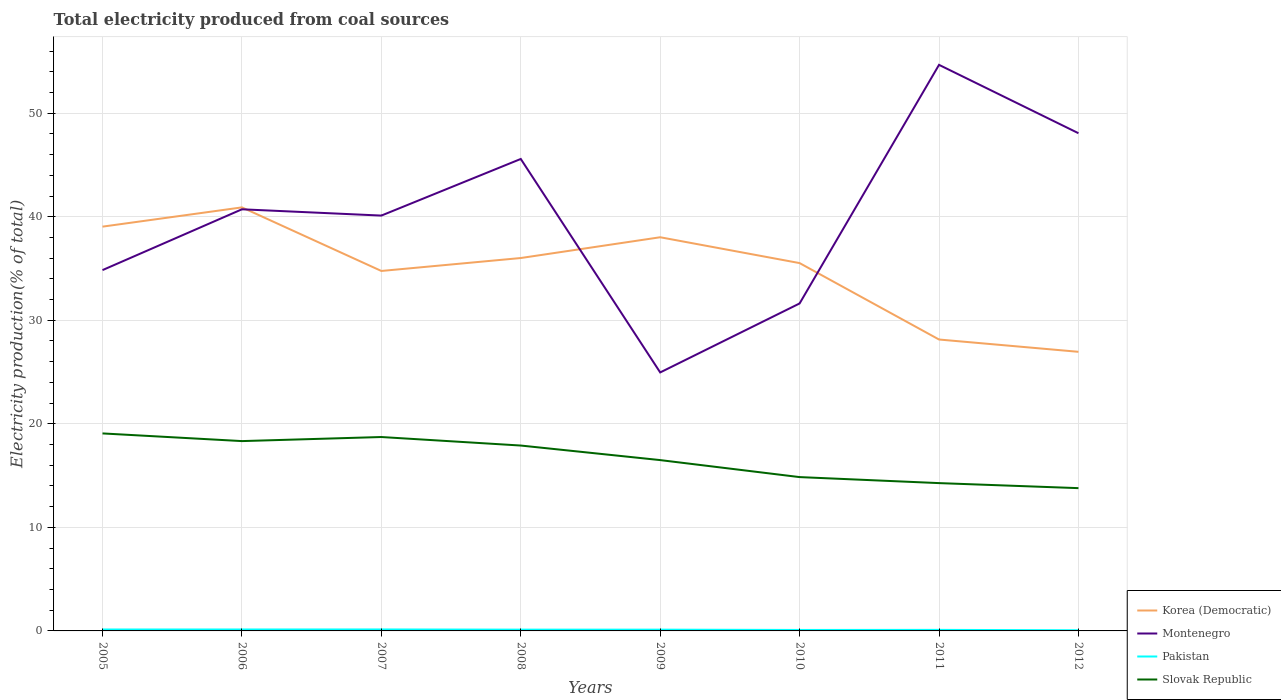Does the line corresponding to Montenegro intersect with the line corresponding to Slovak Republic?
Ensure brevity in your answer.  No. Is the number of lines equal to the number of legend labels?
Ensure brevity in your answer.  Yes. Across all years, what is the maximum total electricity produced in Pakistan?
Make the answer very short. 0.06. What is the total total electricity produced in Pakistan in the graph?
Give a very brief answer. 0.04. What is the difference between the highest and the second highest total electricity produced in Slovak Republic?
Ensure brevity in your answer.  5.29. What is the difference between the highest and the lowest total electricity produced in Slovak Republic?
Provide a short and direct response. 4. Is the total electricity produced in Montenegro strictly greater than the total electricity produced in Korea (Democratic) over the years?
Give a very brief answer. No. How many lines are there?
Provide a succinct answer. 4. How many years are there in the graph?
Provide a succinct answer. 8. What is the difference between two consecutive major ticks on the Y-axis?
Make the answer very short. 10. Does the graph contain any zero values?
Offer a terse response. No. Does the graph contain grids?
Give a very brief answer. Yes. Where does the legend appear in the graph?
Offer a very short reply. Bottom right. What is the title of the graph?
Provide a short and direct response. Total electricity produced from coal sources. What is the label or title of the X-axis?
Offer a terse response. Years. What is the Electricity production(% of total) in Korea (Democratic) in 2005?
Provide a short and direct response. 39.04. What is the Electricity production(% of total) in Montenegro in 2005?
Keep it short and to the point. 34.85. What is the Electricity production(% of total) in Pakistan in 2005?
Provide a succinct answer. 0.14. What is the Electricity production(% of total) in Slovak Republic in 2005?
Give a very brief answer. 19.07. What is the Electricity production(% of total) in Korea (Democratic) in 2006?
Provide a short and direct response. 40.9. What is the Electricity production(% of total) of Montenegro in 2006?
Keep it short and to the point. 40.72. What is the Electricity production(% of total) of Pakistan in 2006?
Offer a very short reply. 0.14. What is the Electricity production(% of total) of Slovak Republic in 2006?
Your answer should be very brief. 18.33. What is the Electricity production(% of total) in Korea (Democratic) in 2007?
Your answer should be very brief. 34.76. What is the Electricity production(% of total) in Montenegro in 2007?
Keep it short and to the point. 40.11. What is the Electricity production(% of total) in Pakistan in 2007?
Your answer should be compact. 0.14. What is the Electricity production(% of total) of Slovak Republic in 2007?
Provide a succinct answer. 18.73. What is the Electricity production(% of total) in Korea (Democratic) in 2008?
Your answer should be compact. 36.01. What is the Electricity production(% of total) in Montenegro in 2008?
Your answer should be compact. 45.58. What is the Electricity production(% of total) in Pakistan in 2008?
Give a very brief answer. 0.12. What is the Electricity production(% of total) of Slovak Republic in 2008?
Provide a succinct answer. 17.9. What is the Electricity production(% of total) in Korea (Democratic) in 2009?
Your answer should be very brief. 38.02. What is the Electricity production(% of total) in Montenegro in 2009?
Give a very brief answer. 24.96. What is the Electricity production(% of total) in Pakistan in 2009?
Your response must be concise. 0.12. What is the Electricity production(% of total) of Slovak Republic in 2009?
Your answer should be compact. 16.5. What is the Electricity production(% of total) in Korea (Democratic) in 2010?
Offer a very short reply. 35.52. What is the Electricity production(% of total) in Montenegro in 2010?
Your answer should be compact. 31.63. What is the Electricity production(% of total) in Pakistan in 2010?
Your response must be concise. 0.09. What is the Electricity production(% of total) of Slovak Republic in 2010?
Provide a succinct answer. 14.86. What is the Electricity production(% of total) of Korea (Democratic) in 2011?
Make the answer very short. 28.14. What is the Electricity production(% of total) of Montenegro in 2011?
Provide a succinct answer. 54.67. What is the Electricity production(% of total) of Pakistan in 2011?
Offer a very short reply. 0.1. What is the Electricity production(% of total) of Slovak Republic in 2011?
Your answer should be compact. 14.27. What is the Electricity production(% of total) of Korea (Democratic) in 2012?
Ensure brevity in your answer.  26.95. What is the Electricity production(% of total) in Montenegro in 2012?
Provide a succinct answer. 48.07. What is the Electricity production(% of total) of Pakistan in 2012?
Keep it short and to the point. 0.06. What is the Electricity production(% of total) of Slovak Republic in 2012?
Provide a succinct answer. 13.79. Across all years, what is the maximum Electricity production(% of total) of Korea (Democratic)?
Your answer should be very brief. 40.9. Across all years, what is the maximum Electricity production(% of total) of Montenegro?
Offer a very short reply. 54.67. Across all years, what is the maximum Electricity production(% of total) of Pakistan?
Offer a very short reply. 0.14. Across all years, what is the maximum Electricity production(% of total) of Slovak Republic?
Provide a short and direct response. 19.07. Across all years, what is the minimum Electricity production(% of total) in Korea (Democratic)?
Your response must be concise. 26.95. Across all years, what is the minimum Electricity production(% of total) in Montenegro?
Your response must be concise. 24.96. Across all years, what is the minimum Electricity production(% of total) of Pakistan?
Provide a short and direct response. 0.06. Across all years, what is the minimum Electricity production(% of total) of Slovak Republic?
Your answer should be compact. 13.79. What is the total Electricity production(% of total) in Korea (Democratic) in the graph?
Keep it short and to the point. 279.36. What is the total Electricity production(% of total) of Montenegro in the graph?
Keep it short and to the point. 320.58. What is the total Electricity production(% of total) in Pakistan in the graph?
Your response must be concise. 0.92. What is the total Electricity production(% of total) of Slovak Republic in the graph?
Offer a very short reply. 133.45. What is the difference between the Electricity production(% of total) in Korea (Democratic) in 2005 and that in 2006?
Your answer should be very brief. -1.86. What is the difference between the Electricity production(% of total) in Montenegro in 2005 and that in 2006?
Give a very brief answer. -5.87. What is the difference between the Electricity production(% of total) of Pakistan in 2005 and that in 2006?
Provide a short and direct response. -0. What is the difference between the Electricity production(% of total) of Slovak Republic in 2005 and that in 2006?
Ensure brevity in your answer.  0.74. What is the difference between the Electricity production(% of total) in Korea (Democratic) in 2005 and that in 2007?
Offer a terse response. 4.28. What is the difference between the Electricity production(% of total) in Montenegro in 2005 and that in 2007?
Offer a very short reply. -5.27. What is the difference between the Electricity production(% of total) of Pakistan in 2005 and that in 2007?
Keep it short and to the point. -0. What is the difference between the Electricity production(% of total) of Slovak Republic in 2005 and that in 2007?
Provide a short and direct response. 0.35. What is the difference between the Electricity production(% of total) in Korea (Democratic) in 2005 and that in 2008?
Provide a short and direct response. 3.03. What is the difference between the Electricity production(% of total) in Montenegro in 2005 and that in 2008?
Provide a succinct answer. -10.73. What is the difference between the Electricity production(% of total) in Pakistan in 2005 and that in 2008?
Offer a terse response. 0.01. What is the difference between the Electricity production(% of total) in Slovak Republic in 2005 and that in 2008?
Make the answer very short. 1.17. What is the difference between the Electricity production(% of total) in Korea (Democratic) in 2005 and that in 2009?
Offer a very short reply. 1.02. What is the difference between the Electricity production(% of total) in Montenegro in 2005 and that in 2009?
Provide a succinct answer. 9.88. What is the difference between the Electricity production(% of total) in Pakistan in 2005 and that in 2009?
Keep it short and to the point. 0.02. What is the difference between the Electricity production(% of total) in Slovak Republic in 2005 and that in 2009?
Keep it short and to the point. 2.58. What is the difference between the Electricity production(% of total) of Korea (Democratic) in 2005 and that in 2010?
Offer a very short reply. 3.52. What is the difference between the Electricity production(% of total) in Montenegro in 2005 and that in 2010?
Offer a very short reply. 3.22. What is the difference between the Electricity production(% of total) of Pakistan in 2005 and that in 2010?
Offer a very short reply. 0.04. What is the difference between the Electricity production(% of total) of Slovak Republic in 2005 and that in 2010?
Provide a succinct answer. 4.22. What is the difference between the Electricity production(% of total) of Korea (Democratic) in 2005 and that in 2011?
Ensure brevity in your answer.  10.9. What is the difference between the Electricity production(% of total) in Montenegro in 2005 and that in 2011?
Give a very brief answer. -19.82. What is the difference between the Electricity production(% of total) in Pakistan in 2005 and that in 2011?
Offer a terse response. 0.04. What is the difference between the Electricity production(% of total) in Slovak Republic in 2005 and that in 2011?
Give a very brief answer. 4.8. What is the difference between the Electricity production(% of total) of Korea (Democratic) in 2005 and that in 2012?
Give a very brief answer. 12.09. What is the difference between the Electricity production(% of total) in Montenegro in 2005 and that in 2012?
Offer a terse response. -13.22. What is the difference between the Electricity production(% of total) of Pakistan in 2005 and that in 2012?
Offer a terse response. 0.07. What is the difference between the Electricity production(% of total) of Slovak Republic in 2005 and that in 2012?
Keep it short and to the point. 5.29. What is the difference between the Electricity production(% of total) of Korea (Democratic) in 2006 and that in 2007?
Give a very brief answer. 6.14. What is the difference between the Electricity production(% of total) in Montenegro in 2006 and that in 2007?
Keep it short and to the point. 0.61. What is the difference between the Electricity production(% of total) in Pakistan in 2006 and that in 2007?
Your response must be concise. -0. What is the difference between the Electricity production(% of total) in Slovak Republic in 2006 and that in 2007?
Offer a terse response. -0.39. What is the difference between the Electricity production(% of total) of Korea (Democratic) in 2006 and that in 2008?
Your answer should be very brief. 4.89. What is the difference between the Electricity production(% of total) of Montenegro in 2006 and that in 2008?
Your answer should be very brief. -4.86. What is the difference between the Electricity production(% of total) in Pakistan in 2006 and that in 2008?
Offer a terse response. 0.02. What is the difference between the Electricity production(% of total) of Slovak Republic in 2006 and that in 2008?
Your answer should be very brief. 0.43. What is the difference between the Electricity production(% of total) in Korea (Democratic) in 2006 and that in 2009?
Offer a very short reply. 2.88. What is the difference between the Electricity production(% of total) of Montenegro in 2006 and that in 2009?
Provide a short and direct response. 15.75. What is the difference between the Electricity production(% of total) in Pakistan in 2006 and that in 2009?
Keep it short and to the point. 0.02. What is the difference between the Electricity production(% of total) in Slovak Republic in 2006 and that in 2009?
Provide a short and direct response. 1.83. What is the difference between the Electricity production(% of total) of Korea (Democratic) in 2006 and that in 2010?
Your response must be concise. 5.38. What is the difference between the Electricity production(% of total) of Montenegro in 2006 and that in 2010?
Your answer should be very brief. 9.09. What is the difference between the Electricity production(% of total) in Pakistan in 2006 and that in 2010?
Make the answer very short. 0.05. What is the difference between the Electricity production(% of total) of Slovak Republic in 2006 and that in 2010?
Make the answer very short. 3.48. What is the difference between the Electricity production(% of total) of Korea (Democratic) in 2006 and that in 2011?
Keep it short and to the point. 12.76. What is the difference between the Electricity production(% of total) in Montenegro in 2006 and that in 2011?
Your answer should be very brief. -13.95. What is the difference between the Electricity production(% of total) in Pakistan in 2006 and that in 2011?
Offer a terse response. 0.04. What is the difference between the Electricity production(% of total) of Slovak Republic in 2006 and that in 2011?
Keep it short and to the point. 4.06. What is the difference between the Electricity production(% of total) in Korea (Democratic) in 2006 and that in 2012?
Your response must be concise. 13.95. What is the difference between the Electricity production(% of total) in Montenegro in 2006 and that in 2012?
Your answer should be compact. -7.35. What is the difference between the Electricity production(% of total) in Pakistan in 2006 and that in 2012?
Offer a terse response. 0.07. What is the difference between the Electricity production(% of total) in Slovak Republic in 2006 and that in 2012?
Your response must be concise. 4.54. What is the difference between the Electricity production(% of total) in Korea (Democratic) in 2007 and that in 2008?
Your response must be concise. -1.25. What is the difference between the Electricity production(% of total) in Montenegro in 2007 and that in 2008?
Make the answer very short. -5.47. What is the difference between the Electricity production(% of total) in Pakistan in 2007 and that in 2008?
Make the answer very short. 0.02. What is the difference between the Electricity production(% of total) of Slovak Republic in 2007 and that in 2008?
Keep it short and to the point. 0.82. What is the difference between the Electricity production(% of total) of Korea (Democratic) in 2007 and that in 2009?
Your answer should be very brief. -3.26. What is the difference between the Electricity production(% of total) in Montenegro in 2007 and that in 2009?
Your answer should be very brief. 15.15. What is the difference between the Electricity production(% of total) of Pakistan in 2007 and that in 2009?
Provide a short and direct response. 0.02. What is the difference between the Electricity production(% of total) of Slovak Republic in 2007 and that in 2009?
Provide a succinct answer. 2.23. What is the difference between the Electricity production(% of total) in Korea (Democratic) in 2007 and that in 2010?
Offer a terse response. -0.76. What is the difference between the Electricity production(% of total) in Montenegro in 2007 and that in 2010?
Your answer should be compact. 8.49. What is the difference between the Electricity production(% of total) in Pakistan in 2007 and that in 2010?
Provide a short and direct response. 0.05. What is the difference between the Electricity production(% of total) of Slovak Republic in 2007 and that in 2010?
Offer a terse response. 3.87. What is the difference between the Electricity production(% of total) in Korea (Democratic) in 2007 and that in 2011?
Provide a succinct answer. 6.62. What is the difference between the Electricity production(% of total) in Montenegro in 2007 and that in 2011?
Your response must be concise. -14.56. What is the difference between the Electricity production(% of total) in Pakistan in 2007 and that in 2011?
Give a very brief answer. 0.04. What is the difference between the Electricity production(% of total) of Slovak Republic in 2007 and that in 2011?
Give a very brief answer. 4.45. What is the difference between the Electricity production(% of total) of Korea (Democratic) in 2007 and that in 2012?
Offer a terse response. 7.81. What is the difference between the Electricity production(% of total) of Montenegro in 2007 and that in 2012?
Keep it short and to the point. -7.95. What is the difference between the Electricity production(% of total) in Pakistan in 2007 and that in 2012?
Make the answer very short. 0.08. What is the difference between the Electricity production(% of total) of Slovak Republic in 2007 and that in 2012?
Make the answer very short. 4.94. What is the difference between the Electricity production(% of total) of Korea (Democratic) in 2008 and that in 2009?
Your response must be concise. -2.01. What is the difference between the Electricity production(% of total) of Montenegro in 2008 and that in 2009?
Your response must be concise. 20.62. What is the difference between the Electricity production(% of total) in Pakistan in 2008 and that in 2009?
Offer a terse response. 0. What is the difference between the Electricity production(% of total) of Slovak Republic in 2008 and that in 2009?
Your answer should be compact. 1.41. What is the difference between the Electricity production(% of total) in Korea (Democratic) in 2008 and that in 2010?
Your answer should be compact. 0.49. What is the difference between the Electricity production(% of total) of Montenegro in 2008 and that in 2010?
Keep it short and to the point. 13.95. What is the difference between the Electricity production(% of total) of Pakistan in 2008 and that in 2010?
Your answer should be compact. 0.03. What is the difference between the Electricity production(% of total) in Slovak Republic in 2008 and that in 2010?
Your answer should be compact. 3.05. What is the difference between the Electricity production(% of total) in Korea (Democratic) in 2008 and that in 2011?
Provide a succinct answer. 7.87. What is the difference between the Electricity production(% of total) of Montenegro in 2008 and that in 2011?
Provide a short and direct response. -9.09. What is the difference between the Electricity production(% of total) of Pakistan in 2008 and that in 2011?
Provide a short and direct response. 0.02. What is the difference between the Electricity production(% of total) of Slovak Republic in 2008 and that in 2011?
Your response must be concise. 3.63. What is the difference between the Electricity production(% of total) in Korea (Democratic) in 2008 and that in 2012?
Offer a very short reply. 9.06. What is the difference between the Electricity production(% of total) of Montenegro in 2008 and that in 2012?
Make the answer very short. -2.49. What is the difference between the Electricity production(% of total) of Pakistan in 2008 and that in 2012?
Keep it short and to the point. 0.06. What is the difference between the Electricity production(% of total) of Slovak Republic in 2008 and that in 2012?
Ensure brevity in your answer.  4.11. What is the difference between the Electricity production(% of total) of Korea (Democratic) in 2009 and that in 2010?
Your answer should be very brief. 2.5. What is the difference between the Electricity production(% of total) in Montenegro in 2009 and that in 2010?
Ensure brevity in your answer.  -6.66. What is the difference between the Electricity production(% of total) in Pakistan in 2009 and that in 2010?
Your response must be concise. 0.03. What is the difference between the Electricity production(% of total) in Slovak Republic in 2009 and that in 2010?
Provide a short and direct response. 1.64. What is the difference between the Electricity production(% of total) in Korea (Democratic) in 2009 and that in 2011?
Provide a short and direct response. 9.88. What is the difference between the Electricity production(% of total) in Montenegro in 2009 and that in 2011?
Ensure brevity in your answer.  -29.7. What is the difference between the Electricity production(% of total) in Pakistan in 2009 and that in 2011?
Ensure brevity in your answer.  0.02. What is the difference between the Electricity production(% of total) of Slovak Republic in 2009 and that in 2011?
Ensure brevity in your answer.  2.22. What is the difference between the Electricity production(% of total) of Korea (Democratic) in 2009 and that in 2012?
Offer a terse response. 11.06. What is the difference between the Electricity production(% of total) of Montenegro in 2009 and that in 2012?
Your response must be concise. -23.1. What is the difference between the Electricity production(% of total) in Pakistan in 2009 and that in 2012?
Your response must be concise. 0.06. What is the difference between the Electricity production(% of total) of Slovak Republic in 2009 and that in 2012?
Your response must be concise. 2.71. What is the difference between the Electricity production(% of total) of Korea (Democratic) in 2010 and that in 2011?
Ensure brevity in your answer.  7.38. What is the difference between the Electricity production(% of total) of Montenegro in 2010 and that in 2011?
Provide a short and direct response. -23.04. What is the difference between the Electricity production(% of total) of Pakistan in 2010 and that in 2011?
Offer a very short reply. -0.01. What is the difference between the Electricity production(% of total) in Slovak Republic in 2010 and that in 2011?
Keep it short and to the point. 0.58. What is the difference between the Electricity production(% of total) in Korea (Democratic) in 2010 and that in 2012?
Your answer should be compact. 8.57. What is the difference between the Electricity production(% of total) in Montenegro in 2010 and that in 2012?
Give a very brief answer. -16.44. What is the difference between the Electricity production(% of total) of Pakistan in 2010 and that in 2012?
Give a very brief answer. 0.03. What is the difference between the Electricity production(% of total) in Slovak Republic in 2010 and that in 2012?
Your response must be concise. 1.07. What is the difference between the Electricity production(% of total) of Korea (Democratic) in 2011 and that in 2012?
Give a very brief answer. 1.19. What is the difference between the Electricity production(% of total) in Montenegro in 2011 and that in 2012?
Offer a terse response. 6.6. What is the difference between the Electricity production(% of total) of Pakistan in 2011 and that in 2012?
Ensure brevity in your answer.  0.04. What is the difference between the Electricity production(% of total) of Slovak Republic in 2011 and that in 2012?
Your response must be concise. 0.49. What is the difference between the Electricity production(% of total) of Korea (Democratic) in 2005 and the Electricity production(% of total) of Montenegro in 2006?
Your answer should be very brief. -1.67. What is the difference between the Electricity production(% of total) of Korea (Democratic) in 2005 and the Electricity production(% of total) of Pakistan in 2006?
Provide a succinct answer. 38.9. What is the difference between the Electricity production(% of total) of Korea (Democratic) in 2005 and the Electricity production(% of total) of Slovak Republic in 2006?
Keep it short and to the point. 20.71. What is the difference between the Electricity production(% of total) in Montenegro in 2005 and the Electricity production(% of total) in Pakistan in 2006?
Your response must be concise. 34.71. What is the difference between the Electricity production(% of total) in Montenegro in 2005 and the Electricity production(% of total) in Slovak Republic in 2006?
Provide a short and direct response. 16.51. What is the difference between the Electricity production(% of total) in Pakistan in 2005 and the Electricity production(% of total) in Slovak Republic in 2006?
Your response must be concise. -18.19. What is the difference between the Electricity production(% of total) of Korea (Democratic) in 2005 and the Electricity production(% of total) of Montenegro in 2007?
Provide a succinct answer. -1.07. What is the difference between the Electricity production(% of total) of Korea (Democratic) in 2005 and the Electricity production(% of total) of Pakistan in 2007?
Your answer should be very brief. 38.9. What is the difference between the Electricity production(% of total) of Korea (Democratic) in 2005 and the Electricity production(% of total) of Slovak Republic in 2007?
Your answer should be compact. 20.32. What is the difference between the Electricity production(% of total) in Montenegro in 2005 and the Electricity production(% of total) in Pakistan in 2007?
Offer a terse response. 34.7. What is the difference between the Electricity production(% of total) in Montenegro in 2005 and the Electricity production(% of total) in Slovak Republic in 2007?
Provide a succinct answer. 16.12. What is the difference between the Electricity production(% of total) of Pakistan in 2005 and the Electricity production(% of total) of Slovak Republic in 2007?
Your answer should be compact. -18.59. What is the difference between the Electricity production(% of total) in Korea (Democratic) in 2005 and the Electricity production(% of total) in Montenegro in 2008?
Offer a terse response. -6.54. What is the difference between the Electricity production(% of total) of Korea (Democratic) in 2005 and the Electricity production(% of total) of Pakistan in 2008?
Your answer should be very brief. 38.92. What is the difference between the Electricity production(% of total) in Korea (Democratic) in 2005 and the Electricity production(% of total) in Slovak Republic in 2008?
Offer a very short reply. 21.14. What is the difference between the Electricity production(% of total) of Montenegro in 2005 and the Electricity production(% of total) of Pakistan in 2008?
Make the answer very short. 34.72. What is the difference between the Electricity production(% of total) in Montenegro in 2005 and the Electricity production(% of total) in Slovak Republic in 2008?
Your response must be concise. 16.94. What is the difference between the Electricity production(% of total) in Pakistan in 2005 and the Electricity production(% of total) in Slovak Republic in 2008?
Provide a short and direct response. -17.77. What is the difference between the Electricity production(% of total) in Korea (Democratic) in 2005 and the Electricity production(% of total) in Montenegro in 2009?
Keep it short and to the point. 14.08. What is the difference between the Electricity production(% of total) in Korea (Democratic) in 2005 and the Electricity production(% of total) in Pakistan in 2009?
Offer a very short reply. 38.92. What is the difference between the Electricity production(% of total) of Korea (Democratic) in 2005 and the Electricity production(% of total) of Slovak Republic in 2009?
Your response must be concise. 22.55. What is the difference between the Electricity production(% of total) of Montenegro in 2005 and the Electricity production(% of total) of Pakistan in 2009?
Give a very brief answer. 34.72. What is the difference between the Electricity production(% of total) of Montenegro in 2005 and the Electricity production(% of total) of Slovak Republic in 2009?
Your response must be concise. 18.35. What is the difference between the Electricity production(% of total) in Pakistan in 2005 and the Electricity production(% of total) in Slovak Republic in 2009?
Your response must be concise. -16.36. What is the difference between the Electricity production(% of total) of Korea (Democratic) in 2005 and the Electricity production(% of total) of Montenegro in 2010?
Offer a terse response. 7.42. What is the difference between the Electricity production(% of total) in Korea (Democratic) in 2005 and the Electricity production(% of total) in Pakistan in 2010?
Provide a succinct answer. 38.95. What is the difference between the Electricity production(% of total) of Korea (Democratic) in 2005 and the Electricity production(% of total) of Slovak Republic in 2010?
Your response must be concise. 24.19. What is the difference between the Electricity production(% of total) of Montenegro in 2005 and the Electricity production(% of total) of Pakistan in 2010?
Offer a terse response. 34.75. What is the difference between the Electricity production(% of total) in Montenegro in 2005 and the Electricity production(% of total) in Slovak Republic in 2010?
Your response must be concise. 19.99. What is the difference between the Electricity production(% of total) in Pakistan in 2005 and the Electricity production(% of total) in Slovak Republic in 2010?
Provide a succinct answer. -14.72. What is the difference between the Electricity production(% of total) in Korea (Democratic) in 2005 and the Electricity production(% of total) in Montenegro in 2011?
Provide a succinct answer. -15.63. What is the difference between the Electricity production(% of total) in Korea (Democratic) in 2005 and the Electricity production(% of total) in Pakistan in 2011?
Provide a succinct answer. 38.94. What is the difference between the Electricity production(% of total) in Korea (Democratic) in 2005 and the Electricity production(% of total) in Slovak Republic in 2011?
Your answer should be compact. 24.77. What is the difference between the Electricity production(% of total) in Montenegro in 2005 and the Electricity production(% of total) in Pakistan in 2011?
Keep it short and to the point. 34.75. What is the difference between the Electricity production(% of total) in Montenegro in 2005 and the Electricity production(% of total) in Slovak Republic in 2011?
Keep it short and to the point. 20.57. What is the difference between the Electricity production(% of total) in Pakistan in 2005 and the Electricity production(% of total) in Slovak Republic in 2011?
Your answer should be compact. -14.14. What is the difference between the Electricity production(% of total) in Korea (Democratic) in 2005 and the Electricity production(% of total) in Montenegro in 2012?
Offer a terse response. -9.02. What is the difference between the Electricity production(% of total) of Korea (Democratic) in 2005 and the Electricity production(% of total) of Pakistan in 2012?
Ensure brevity in your answer.  38.98. What is the difference between the Electricity production(% of total) of Korea (Democratic) in 2005 and the Electricity production(% of total) of Slovak Republic in 2012?
Your answer should be very brief. 25.25. What is the difference between the Electricity production(% of total) in Montenegro in 2005 and the Electricity production(% of total) in Pakistan in 2012?
Offer a very short reply. 34.78. What is the difference between the Electricity production(% of total) of Montenegro in 2005 and the Electricity production(% of total) of Slovak Republic in 2012?
Provide a succinct answer. 21.06. What is the difference between the Electricity production(% of total) of Pakistan in 2005 and the Electricity production(% of total) of Slovak Republic in 2012?
Provide a succinct answer. -13.65. What is the difference between the Electricity production(% of total) of Korea (Democratic) in 2006 and the Electricity production(% of total) of Montenegro in 2007?
Provide a short and direct response. 0.79. What is the difference between the Electricity production(% of total) in Korea (Democratic) in 2006 and the Electricity production(% of total) in Pakistan in 2007?
Keep it short and to the point. 40.76. What is the difference between the Electricity production(% of total) in Korea (Democratic) in 2006 and the Electricity production(% of total) in Slovak Republic in 2007?
Make the answer very short. 22.18. What is the difference between the Electricity production(% of total) of Montenegro in 2006 and the Electricity production(% of total) of Pakistan in 2007?
Ensure brevity in your answer.  40.58. What is the difference between the Electricity production(% of total) of Montenegro in 2006 and the Electricity production(% of total) of Slovak Republic in 2007?
Provide a succinct answer. 21.99. What is the difference between the Electricity production(% of total) in Pakistan in 2006 and the Electricity production(% of total) in Slovak Republic in 2007?
Provide a succinct answer. -18.59. What is the difference between the Electricity production(% of total) of Korea (Democratic) in 2006 and the Electricity production(% of total) of Montenegro in 2008?
Provide a succinct answer. -4.68. What is the difference between the Electricity production(% of total) in Korea (Democratic) in 2006 and the Electricity production(% of total) in Pakistan in 2008?
Your response must be concise. 40.78. What is the difference between the Electricity production(% of total) of Korea (Democratic) in 2006 and the Electricity production(% of total) of Slovak Republic in 2008?
Your response must be concise. 23. What is the difference between the Electricity production(% of total) of Montenegro in 2006 and the Electricity production(% of total) of Pakistan in 2008?
Provide a succinct answer. 40.59. What is the difference between the Electricity production(% of total) of Montenegro in 2006 and the Electricity production(% of total) of Slovak Republic in 2008?
Your answer should be compact. 22.81. What is the difference between the Electricity production(% of total) of Pakistan in 2006 and the Electricity production(% of total) of Slovak Republic in 2008?
Your response must be concise. -17.76. What is the difference between the Electricity production(% of total) in Korea (Democratic) in 2006 and the Electricity production(% of total) in Montenegro in 2009?
Your response must be concise. 15.94. What is the difference between the Electricity production(% of total) in Korea (Democratic) in 2006 and the Electricity production(% of total) in Pakistan in 2009?
Ensure brevity in your answer.  40.78. What is the difference between the Electricity production(% of total) of Korea (Democratic) in 2006 and the Electricity production(% of total) of Slovak Republic in 2009?
Your response must be concise. 24.41. What is the difference between the Electricity production(% of total) in Montenegro in 2006 and the Electricity production(% of total) in Pakistan in 2009?
Provide a short and direct response. 40.6. What is the difference between the Electricity production(% of total) in Montenegro in 2006 and the Electricity production(% of total) in Slovak Republic in 2009?
Your response must be concise. 24.22. What is the difference between the Electricity production(% of total) of Pakistan in 2006 and the Electricity production(% of total) of Slovak Republic in 2009?
Offer a very short reply. -16.36. What is the difference between the Electricity production(% of total) in Korea (Democratic) in 2006 and the Electricity production(% of total) in Montenegro in 2010?
Ensure brevity in your answer.  9.28. What is the difference between the Electricity production(% of total) in Korea (Democratic) in 2006 and the Electricity production(% of total) in Pakistan in 2010?
Offer a very short reply. 40.81. What is the difference between the Electricity production(% of total) of Korea (Democratic) in 2006 and the Electricity production(% of total) of Slovak Republic in 2010?
Your response must be concise. 26.05. What is the difference between the Electricity production(% of total) of Montenegro in 2006 and the Electricity production(% of total) of Pakistan in 2010?
Give a very brief answer. 40.62. What is the difference between the Electricity production(% of total) in Montenegro in 2006 and the Electricity production(% of total) in Slovak Republic in 2010?
Your response must be concise. 25.86. What is the difference between the Electricity production(% of total) of Pakistan in 2006 and the Electricity production(% of total) of Slovak Republic in 2010?
Keep it short and to the point. -14.72. What is the difference between the Electricity production(% of total) of Korea (Democratic) in 2006 and the Electricity production(% of total) of Montenegro in 2011?
Your answer should be very brief. -13.77. What is the difference between the Electricity production(% of total) in Korea (Democratic) in 2006 and the Electricity production(% of total) in Pakistan in 2011?
Make the answer very short. 40.8. What is the difference between the Electricity production(% of total) in Korea (Democratic) in 2006 and the Electricity production(% of total) in Slovak Republic in 2011?
Your answer should be very brief. 26.63. What is the difference between the Electricity production(% of total) of Montenegro in 2006 and the Electricity production(% of total) of Pakistan in 2011?
Make the answer very short. 40.62. What is the difference between the Electricity production(% of total) in Montenegro in 2006 and the Electricity production(% of total) in Slovak Republic in 2011?
Your response must be concise. 26.44. What is the difference between the Electricity production(% of total) in Pakistan in 2006 and the Electricity production(% of total) in Slovak Republic in 2011?
Ensure brevity in your answer.  -14.14. What is the difference between the Electricity production(% of total) of Korea (Democratic) in 2006 and the Electricity production(% of total) of Montenegro in 2012?
Offer a terse response. -7.16. What is the difference between the Electricity production(% of total) in Korea (Democratic) in 2006 and the Electricity production(% of total) in Pakistan in 2012?
Ensure brevity in your answer.  40.84. What is the difference between the Electricity production(% of total) of Korea (Democratic) in 2006 and the Electricity production(% of total) of Slovak Republic in 2012?
Offer a very short reply. 27.11. What is the difference between the Electricity production(% of total) of Montenegro in 2006 and the Electricity production(% of total) of Pakistan in 2012?
Keep it short and to the point. 40.65. What is the difference between the Electricity production(% of total) in Montenegro in 2006 and the Electricity production(% of total) in Slovak Republic in 2012?
Give a very brief answer. 26.93. What is the difference between the Electricity production(% of total) of Pakistan in 2006 and the Electricity production(% of total) of Slovak Republic in 2012?
Ensure brevity in your answer.  -13.65. What is the difference between the Electricity production(% of total) in Korea (Democratic) in 2007 and the Electricity production(% of total) in Montenegro in 2008?
Your answer should be compact. -10.82. What is the difference between the Electricity production(% of total) in Korea (Democratic) in 2007 and the Electricity production(% of total) in Pakistan in 2008?
Your answer should be very brief. 34.64. What is the difference between the Electricity production(% of total) of Korea (Democratic) in 2007 and the Electricity production(% of total) of Slovak Republic in 2008?
Your response must be concise. 16.86. What is the difference between the Electricity production(% of total) in Montenegro in 2007 and the Electricity production(% of total) in Pakistan in 2008?
Provide a short and direct response. 39.99. What is the difference between the Electricity production(% of total) in Montenegro in 2007 and the Electricity production(% of total) in Slovak Republic in 2008?
Your answer should be compact. 22.21. What is the difference between the Electricity production(% of total) of Pakistan in 2007 and the Electricity production(% of total) of Slovak Republic in 2008?
Provide a succinct answer. -17.76. What is the difference between the Electricity production(% of total) in Korea (Democratic) in 2007 and the Electricity production(% of total) in Montenegro in 2009?
Your answer should be compact. 9.8. What is the difference between the Electricity production(% of total) of Korea (Democratic) in 2007 and the Electricity production(% of total) of Pakistan in 2009?
Keep it short and to the point. 34.64. What is the difference between the Electricity production(% of total) in Korea (Democratic) in 2007 and the Electricity production(% of total) in Slovak Republic in 2009?
Offer a terse response. 18.27. What is the difference between the Electricity production(% of total) of Montenegro in 2007 and the Electricity production(% of total) of Pakistan in 2009?
Your answer should be compact. 39.99. What is the difference between the Electricity production(% of total) of Montenegro in 2007 and the Electricity production(% of total) of Slovak Republic in 2009?
Your answer should be very brief. 23.61. What is the difference between the Electricity production(% of total) of Pakistan in 2007 and the Electricity production(% of total) of Slovak Republic in 2009?
Provide a succinct answer. -16.36. What is the difference between the Electricity production(% of total) of Korea (Democratic) in 2007 and the Electricity production(% of total) of Montenegro in 2010?
Ensure brevity in your answer.  3.14. What is the difference between the Electricity production(% of total) in Korea (Democratic) in 2007 and the Electricity production(% of total) in Pakistan in 2010?
Your answer should be very brief. 34.67. What is the difference between the Electricity production(% of total) in Korea (Democratic) in 2007 and the Electricity production(% of total) in Slovak Republic in 2010?
Your response must be concise. 19.91. What is the difference between the Electricity production(% of total) in Montenegro in 2007 and the Electricity production(% of total) in Pakistan in 2010?
Offer a terse response. 40.02. What is the difference between the Electricity production(% of total) in Montenegro in 2007 and the Electricity production(% of total) in Slovak Republic in 2010?
Give a very brief answer. 25.26. What is the difference between the Electricity production(% of total) of Pakistan in 2007 and the Electricity production(% of total) of Slovak Republic in 2010?
Offer a very short reply. -14.71. What is the difference between the Electricity production(% of total) of Korea (Democratic) in 2007 and the Electricity production(% of total) of Montenegro in 2011?
Your answer should be very brief. -19.91. What is the difference between the Electricity production(% of total) of Korea (Democratic) in 2007 and the Electricity production(% of total) of Pakistan in 2011?
Give a very brief answer. 34.66. What is the difference between the Electricity production(% of total) in Korea (Democratic) in 2007 and the Electricity production(% of total) in Slovak Republic in 2011?
Give a very brief answer. 20.49. What is the difference between the Electricity production(% of total) of Montenegro in 2007 and the Electricity production(% of total) of Pakistan in 2011?
Your answer should be very brief. 40.01. What is the difference between the Electricity production(% of total) of Montenegro in 2007 and the Electricity production(% of total) of Slovak Republic in 2011?
Ensure brevity in your answer.  25.84. What is the difference between the Electricity production(% of total) of Pakistan in 2007 and the Electricity production(% of total) of Slovak Republic in 2011?
Provide a succinct answer. -14.13. What is the difference between the Electricity production(% of total) of Korea (Democratic) in 2007 and the Electricity production(% of total) of Montenegro in 2012?
Offer a very short reply. -13.3. What is the difference between the Electricity production(% of total) of Korea (Democratic) in 2007 and the Electricity production(% of total) of Pakistan in 2012?
Offer a terse response. 34.7. What is the difference between the Electricity production(% of total) in Korea (Democratic) in 2007 and the Electricity production(% of total) in Slovak Republic in 2012?
Your answer should be very brief. 20.97. What is the difference between the Electricity production(% of total) of Montenegro in 2007 and the Electricity production(% of total) of Pakistan in 2012?
Your answer should be very brief. 40.05. What is the difference between the Electricity production(% of total) of Montenegro in 2007 and the Electricity production(% of total) of Slovak Republic in 2012?
Keep it short and to the point. 26.32. What is the difference between the Electricity production(% of total) in Pakistan in 2007 and the Electricity production(% of total) in Slovak Republic in 2012?
Make the answer very short. -13.65. What is the difference between the Electricity production(% of total) in Korea (Democratic) in 2008 and the Electricity production(% of total) in Montenegro in 2009?
Your response must be concise. 11.05. What is the difference between the Electricity production(% of total) of Korea (Democratic) in 2008 and the Electricity production(% of total) of Pakistan in 2009?
Give a very brief answer. 35.89. What is the difference between the Electricity production(% of total) of Korea (Democratic) in 2008 and the Electricity production(% of total) of Slovak Republic in 2009?
Keep it short and to the point. 19.51. What is the difference between the Electricity production(% of total) in Montenegro in 2008 and the Electricity production(% of total) in Pakistan in 2009?
Your response must be concise. 45.46. What is the difference between the Electricity production(% of total) in Montenegro in 2008 and the Electricity production(% of total) in Slovak Republic in 2009?
Ensure brevity in your answer.  29.08. What is the difference between the Electricity production(% of total) of Pakistan in 2008 and the Electricity production(% of total) of Slovak Republic in 2009?
Ensure brevity in your answer.  -16.37. What is the difference between the Electricity production(% of total) in Korea (Democratic) in 2008 and the Electricity production(% of total) in Montenegro in 2010?
Your answer should be compact. 4.39. What is the difference between the Electricity production(% of total) in Korea (Democratic) in 2008 and the Electricity production(% of total) in Pakistan in 2010?
Keep it short and to the point. 35.92. What is the difference between the Electricity production(% of total) in Korea (Democratic) in 2008 and the Electricity production(% of total) in Slovak Republic in 2010?
Your answer should be very brief. 21.16. What is the difference between the Electricity production(% of total) in Montenegro in 2008 and the Electricity production(% of total) in Pakistan in 2010?
Provide a short and direct response. 45.49. What is the difference between the Electricity production(% of total) of Montenegro in 2008 and the Electricity production(% of total) of Slovak Republic in 2010?
Offer a terse response. 30.72. What is the difference between the Electricity production(% of total) in Pakistan in 2008 and the Electricity production(% of total) in Slovak Republic in 2010?
Offer a very short reply. -14.73. What is the difference between the Electricity production(% of total) of Korea (Democratic) in 2008 and the Electricity production(% of total) of Montenegro in 2011?
Make the answer very short. -18.66. What is the difference between the Electricity production(% of total) in Korea (Democratic) in 2008 and the Electricity production(% of total) in Pakistan in 2011?
Your answer should be compact. 35.91. What is the difference between the Electricity production(% of total) in Korea (Democratic) in 2008 and the Electricity production(% of total) in Slovak Republic in 2011?
Offer a terse response. 21.74. What is the difference between the Electricity production(% of total) of Montenegro in 2008 and the Electricity production(% of total) of Pakistan in 2011?
Your answer should be very brief. 45.48. What is the difference between the Electricity production(% of total) in Montenegro in 2008 and the Electricity production(% of total) in Slovak Republic in 2011?
Your answer should be very brief. 31.31. What is the difference between the Electricity production(% of total) of Pakistan in 2008 and the Electricity production(% of total) of Slovak Republic in 2011?
Your response must be concise. -14.15. What is the difference between the Electricity production(% of total) in Korea (Democratic) in 2008 and the Electricity production(% of total) in Montenegro in 2012?
Your answer should be compact. -12.05. What is the difference between the Electricity production(% of total) of Korea (Democratic) in 2008 and the Electricity production(% of total) of Pakistan in 2012?
Provide a short and direct response. 35.95. What is the difference between the Electricity production(% of total) in Korea (Democratic) in 2008 and the Electricity production(% of total) in Slovak Republic in 2012?
Provide a succinct answer. 22.22. What is the difference between the Electricity production(% of total) of Montenegro in 2008 and the Electricity production(% of total) of Pakistan in 2012?
Provide a short and direct response. 45.52. What is the difference between the Electricity production(% of total) of Montenegro in 2008 and the Electricity production(% of total) of Slovak Republic in 2012?
Your answer should be very brief. 31.79. What is the difference between the Electricity production(% of total) of Pakistan in 2008 and the Electricity production(% of total) of Slovak Republic in 2012?
Your response must be concise. -13.67. What is the difference between the Electricity production(% of total) of Korea (Democratic) in 2009 and the Electricity production(% of total) of Montenegro in 2010?
Your answer should be very brief. 6.39. What is the difference between the Electricity production(% of total) of Korea (Democratic) in 2009 and the Electricity production(% of total) of Pakistan in 2010?
Your response must be concise. 37.93. What is the difference between the Electricity production(% of total) in Korea (Democratic) in 2009 and the Electricity production(% of total) in Slovak Republic in 2010?
Give a very brief answer. 23.16. What is the difference between the Electricity production(% of total) of Montenegro in 2009 and the Electricity production(% of total) of Pakistan in 2010?
Offer a terse response. 24.87. What is the difference between the Electricity production(% of total) of Montenegro in 2009 and the Electricity production(% of total) of Slovak Republic in 2010?
Provide a short and direct response. 10.11. What is the difference between the Electricity production(% of total) of Pakistan in 2009 and the Electricity production(% of total) of Slovak Republic in 2010?
Your answer should be compact. -14.73. What is the difference between the Electricity production(% of total) in Korea (Democratic) in 2009 and the Electricity production(% of total) in Montenegro in 2011?
Offer a terse response. -16.65. What is the difference between the Electricity production(% of total) of Korea (Democratic) in 2009 and the Electricity production(% of total) of Pakistan in 2011?
Your response must be concise. 37.92. What is the difference between the Electricity production(% of total) of Korea (Democratic) in 2009 and the Electricity production(% of total) of Slovak Republic in 2011?
Offer a terse response. 23.74. What is the difference between the Electricity production(% of total) in Montenegro in 2009 and the Electricity production(% of total) in Pakistan in 2011?
Ensure brevity in your answer.  24.86. What is the difference between the Electricity production(% of total) of Montenegro in 2009 and the Electricity production(% of total) of Slovak Republic in 2011?
Provide a short and direct response. 10.69. What is the difference between the Electricity production(% of total) in Pakistan in 2009 and the Electricity production(% of total) in Slovak Republic in 2011?
Provide a succinct answer. -14.15. What is the difference between the Electricity production(% of total) in Korea (Democratic) in 2009 and the Electricity production(% of total) in Montenegro in 2012?
Ensure brevity in your answer.  -10.05. What is the difference between the Electricity production(% of total) in Korea (Democratic) in 2009 and the Electricity production(% of total) in Pakistan in 2012?
Offer a very short reply. 37.96. What is the difference between the Electricity production(% of total) of Korea (Democratic) in 2009 and the Electricity production(% of total) of Slovak Republic in 2012?
Keep it short and to the point. 24.23. What is the difference between the Electricity production(% of total) of Montenegro in 2009 and the Electricity production(% of total) of Pakistan in 2012?
Offer a terse response. 24.9. What is the difference between the Electricity production(% of total) in Montenegro in 2009 and the Electricity production(% of total) in Slovak Republic in 2012?
Ensure brevity in your answer.  11.18. What is the difference between the Electricity production(% of total) of Pakistan in 2009 and the Electricity production(% of total) of Slovak Republic in 2012?
Your answer should be very brief. -13.67. What is the difference between the Electricity production(% of total) of Korea (Democratic) in 2010 and the Electricity production(% of total) of Montenegro in 2011?
Offer a terse response. -19.15. What is the difference between the Electricity production(% of total) in Korea (Democratic) in 2010 and the Electricity production(% of total) in Pakistan in 2011?
Offer a very short reply. 35.42. What is the difference between the Electricity production(% of total) in Korea (Democratic) in 2010 and the Electricity production(% of total) in Slovak Republic in 2011?
Offer a terse response. 21.25. What is the difference between the Electricity production(% of total) of Montenegro in 2010 and the Electricity production(% of total) of Pakistan in 2011?
Provide a succinct answer. 31.53. What is the difference between the Electricity production(% of total) in Montenegro in 2010 and the Electricity production(% of total) in Slovak Republic in 2011?
Make the answer very short. 17.35. What is the difference between the Electricity production(% of total) in Pakistan in 2010 and the Electricity production(% of total) in Slovak Republic in 2011?
Ensure brevity in your answer.  -14.18. What is the difference between the Electricity production(% of total) of Korea (Democratic) in 2010 and the Electricity production(% of total) of Montenegro in 2012?
Offer a very short reply. -12.54. What is the difference between the Electricity production(% of total) in Korea (Democratic) in 2010 and the Electricity production(% of total) in Pakistan in 2012?
Provide a short and direct response. 35.46. What is the difference between the Electricity production(% of total) in Korea (Democratic) in 2010 and the Electricity production(% of total) in Slovak Republic in 2012?
Give a very brief answer. 21.73. What is the difference between the Electricity production(% of total) of Montenegro in 2010 and the Electricity production(% of total) of Pakistan in 2012?
Your response must be concise. 31.56. What is the difference between the Electricity production(% of total) in Montenegro in 2010 and the Electricity production(% of total) in Slovak Republic in 2012?
Give a very brief answer. 17.84. What is the difference between the Electricity production(% of total) of Pakistan in 2010 and the Electricity production(% of total) of Slovak Republic in 2012?
Your answer should be very brief. -13.7. What is the difference between the Electricity production(% of total) of Korea (Democratic) in 2011 and the Electricity production(% of total) of Montenegro in 2012?
Your answer should be compact. -19.92. What is the difference between the Electricity production(% of total) of Korea (Democratic) in 2011 and the Electricity production(% of total) of Pakistan in 2012?
Provide a succinct answer. 28.08. What is the difference between the Electricity production(% of total) of Korea (Democratic) in 2011 and the Electricity production(% of total) of Slovak Republic in 2012?
Offer a terse response. 14.35. What is the difference between the Electricity production(% of total) of Montenegro in 2011 and the Electricity production(% of total) of Pakistan in 2012?
Your response must be concise. 54.61. What is the difference between the Electricity production(% of total) of Montenegro in 2011 and the Electricity production(% of total) of Slovak Republic in 2012?
Make the answer very short. 40.88. What is the difference between the Electricity production(% of total) in Pakistan in 2011 and the Electricity production(% of total) in Slovak Republic in 2012?
Keep it short and to the point. -13.69. What is the average Electricity production(% of total) in Korea (Democratic) per year?
Make the answer very short. 34.92. What is the average Electricity production(% of total) of Montenegro per year?
Your response must be concise. 40.07. What is the average Electricity production(% of total) in Pakistan per year?
Your response must be concise. 0.12. What is the average Electricity production(% of total) in Slovak Republic per year?
Provide a short and direct response. 16.68. In the year 2005, what is the difference between the Electricity production(% of total) in Korea (Democratic) and Electricity production(% of total) in Montenegro?
Your response must be concise. 4.2. In the year 2005, what is the difference between the Electricity production(% of total) of Korea (Democratic) and Electricity production(% of total) of Pakistan?
Keep it short and to the point. 38.91. In the year 2005, what is the difference between the Electricity production(% of total) in Korea (Democratic) and Electricity production(% of total) in Slovak Republic?
Give a very brief answer. 19.97. In the year 2005, what is the difference between the Electricity production(% of total) in Montenegro and Electricity production(% of total) in Pakistan?
Offer a very short reply. 34.71. In the year 2005, what is the difference between the Electricity production(% of total) in Montenegro and Electricity production(% of total) in Slovak Republic?
Give a very brief answer. 15.77. In the year 2005, what is the difference between the Electricity production(% of total) in Pakistan and Electricity production(% of total) in Slovak Republic?
Your answer should be very brief. -18.94. In the year 2006, what is the difference between the Electricity production(% of total) of Korea (Democratic) and Electricity production(% of total) of Montenegro?
Offer a terse response. 0.18. In the year 2006, what is the difference between the Electricity production(% of total) in Korea (Democratic) and Electricity production(% of total) in Pakistan?
Give a very brief answer. 40.76. In the year 2006, what is the difference between the Electricity production(% of total) in Korea (Democratic) and Electricity production(% of total) in Slovak Republic?
Your answer should be very brief. 22.57. In the year 2006, what is the difference between the Electricity production(% of total) of Montenegro and Electricity production(% of total) of Pakistan?
Ensure brevity in your answer.  40.58. In the year 2006, what is the difference between the Electricity production(% of total) in Montenegro and Electricity production(% of total) in Slovak Republic?
Your response must be concise. 22.39. In the year 2006, what is the difference between the Electricity production(% of total) of Pakistan and Electricity production(% of total) of Slovak Republic?
Your answer should be very brief. -18.19. In the year 2007, what is the difference between the Electricity production(% of total) in Korea (Democratic) and Electricity production(% of total) in Montenegro?
Keep it short and to the point. -5.35. In the year 2007, what is the difference between the Electricity production(% of total) in Korea (Democratic) and Electricity production(% of total) in Pakistan?
Ensure brevity in your answer.  34.62. In the year 2007, what is the difference between the Electricity production(% of total) in Korea (Democratic) and Electricity production(% of total) in Slovak Republic?
Your answer should be compact. 16.04. In the year 2007, what is the difference between the Electricity production(% of total) in Montenegro and Electricity production(% of total) in Pakistan?
Provide a short and direct response. 39.97. In the year 2007, what is the difference between the Electricity production(% of total) in Montenegro and Electricity production(% of total) in Slovak Republic?
Make the answer very short. 21.39. In the year 2007, what is the difference between the Electricity production(% of total) of Pakistan and Electricity production(% of total) of Slovak Republic?
Provide a succinct answer. -18.58. In the year 2008, what is the difference between the Electricity production(% of total) in Korea (Democratic) and Electricity production(% of total) in Montenegro?
Provide a succinct answer. -9.57. In the year 2008, what is the difference between the Electricity production(% of total) in Korea (Democratic) and Electricity production(% of total) in Pakistan?
Offer a very short reply. 35.89. In the year 2008, what is the difference between the Electricity production(% of total) of Korea (Democratic) and Electricity production(% of total) of Slovak Republic?
Provide a short and direct response. 18.11. In the year 2008, what is the difference between the Electricity production(% of total) of Montenegro and Electricity production(% of total) of Pakistan?
Your answer should be very brief. 45.46. In the year 2008, what is the difference between the Electricity production(% of total) of Montenegro and Electricity production(% of total) of Slovak Republic?
Provide a succinct answer. 27.68. In the year 2008, what is the difference between the Electricity production(% of total) in Pakistan and Electricity production(% of total) in Slovak Republic?
Your answer should be compact. -17.78. In the year 2009, what is the difference between the Electricity production(% of total) of Korea (Democratic) and Electricity production(% of total) of Montenegro?
Offer a very short reply. 13.06. In the year 2009, what is the difference between the Electricity production(% of total) in Korea (Democratic) and Electricity production(% of total) in Pakistan?
Make the answer very short. 37.9. In the year 2009, what is the difference between the Electricity production(% of total) of Korea (Democratic) and Electricity production(% of total) of Slovak Republic?
Ensure brevity in your answer.  21.52. In the year 2009, what is the difference between the Electricity production(% of total) in Montenegro and Electricity production(% of total) in Pakistan?
Your answer should be very brief. 24.84. In the year 2009, what is the difference between the Electricity production(% of total) of Montenegro and Electricity production(% of total) of Slovak Republic?
Provide a short and direct response. 8.47. In the year 2009, what is the difference between the Electricity production(% of total) of Pakistan and Electricity production(% of total) of Slovak Republic?
Keep it short and to the point. -16.38. In the year 2010, what is the difference between the Electricity production(% of total) of Korea (Democratic) and Electricity production(% of total) of Montenegro?
Your answer should be compact. 3.9. In the year 2010, what is the difference between the Electricity production(% of total) of Korea (Democratic) and Electricity production(% of total) of Pakistan?
Your response must be concise. 35.43. In the year 2010, what is the difference between the Electricity production(% of total) of Korea (Democratic) and Electricity production(% of total) of Slovak Republic?
Offer a terse response. 20.67. In the year 2010, what is the difference between the Electricity production(% of total) of Montenegro and Electricity production(% of total) of Pakistan?
Offer a terse response. 31.53. In the year 2010, what is the difference between the Electricity production(% of total) of Montenegro and Electricity production(% of total) of Slovak Republic?
Ensure brevity in your answer.  16.77. In the year 2010, what is the difference between the Electricity production(% of total) in Pakistan and Electricity production(% of total) in Slovak Republic?
Offer a very short reply. -14.76. In the year 2011, what is the difference between the Electricity production(% of total) in Korea (Democratic) and Electricity production(% of total) in Montenegro?
Provide a succinct answer. -26.53. In the year 2011, what is the difference between the Electricity production(% of total) in Korea (Democratic) and Electricity production(% of total) in Pakistan?
Provide a succinct answer. 28.04. In the year 2011, what is the difference between the Electricity production(% of total) of Korea (Democratic) and Electricity production(% of total) of Slovak Republic?
Offer a terse response. 13.87. In the year 2011, what is the difference between the Electricity production(% of total) in Montenegro and Electricity production(% of total) in Pakistan?
Provide a short and direct response. 54.57. In the year 2011, what is the difference between the Electricity production(% of total) of Montenegro and Electricity production(% of total) of Slovak Republic?
Provide a short and direct response. 40.39. In the year 2011, what is the difference between the Electricity production(% of total) in Pakistan and Electricity production(% of total) in Slovak Republic?
Make the answer very short. -14.17. In the year 2012, what is the difference between the Electricity production(% of total) of Korea (Democratic) and Electricity production(% of total) of Montenegro?
Your answer should be very brief. -21.11. In the year 2012, what is the difference between the Electricity production(% of total) in Korea (Democratic) and Electricity production(% of total) in Pakistan?
Make the answer very short. 26.89. In the year 2012, what is the difference between the Electricity production(% of total) of Korea (Democratic) and Electricity production(% of total) of Slovak Republic?
Provide a succinct answer. 13.17. In the year 2012, what is the difference between the Electricity production(% of total) in Montenegro and Electricity production(% of total) in Pakistan?
Give a very brief answer. 48. In the year 2012, what is the difference between the Electricity production(% of total) of Montenegro and Electricity production(% of total) of Slovak Republic?
Your answer should be very brief. 34.28. In the year 2012, what is the difference between the Electricity production(% of total) in Pakistan and Electricity production(% of total) in Slovak Republic?
Offer a terse response. -13.72. What is the ratio of the Electricity production(% of total) in Korea (Democratic) in 2005 to that in 2006?
Provide a short and direct response. 0.95. What is the ratio of the Electricity production(% of total) of Montenegro in 2005 to that in 2006?
Keep it short and to the point. 0.86. What is the ratio of the Electricity production(% of total) in Slovak Republic in 2005 to that in 2006?
Keep it short and to the point. 1.04. What is the ratio of the Electricity production(% of total) of Korea (Democratic) in 2005 to that in 2007?
Give a very brief answer. 1.12. What is the ratio of the Electricity production(% of total) in Montenegro in 2005 to that in 2007?
Ensure brevity in your answer.  0.87. What is the ratio of the Electricity production(% of total) of Pakistan in 2005 to that in 2007?
Provide a short and direct response. 0.97. What is the ratio of the Electricity production(% of total) of Slovak Republic in 2005 to that in 2007?
Your response must be concise. 1.02. What is the ratio of the Electricity production(% of total) of Korea (Democratic) in 2005 to that in 2008?
Provide a short and direct response. 1.08. What is the ratio of the Electricity production(% of total) in Montenegro in 2005 to that in 2008?
Provide a succinct answer. 0.76. What is the ratio of the Electricity production(% of total) in Pakistan in 2005 to that in 2008?
Your response must be concise. 1.12. What is the ratio of the Electricity production(% of total) in Slovak Republic in 2005 to that in 2008?
Provide a succinct answer. 1.07. What is the ratio of the Electricity production(% of total) of Korea (Democratic) in 2005 to that in 2009?
Your response must be concise. 1.03. What is the ratio of the Electricity production(% of total) in Montenegro in 2005 to that in 2009?
Give a very brief answer. 1.4. What is the ratio of the Electricity production(% of total) of Pakistan in 2005 to that in 2009?
Keep it short and to the point. 1.13. What is the ratio of the Electricity production(% of total) of Slovak Republic in 2005 to that in 2009?
Your answer should be compact. 1.16. What is the ratio of the Electricity production(% of total) in Korea (Democratic) in 2005 to that in 2010?
Your answer should be very brief. 1.1. What is the ratio of the Electricity production(% of total) of Montenegro in 2005 to that in 2010?
Give a very brief answer. 1.1. What is the ratio of the Electricity production(% of total) of Pakistan in 2005 to that in 2010?
Your response must be concise. 1.48. What is the ratio of the Electricity production(% of total) in Slovak Republic in 2005 to that in 2010?
Give a very brief answer. 1.28. What is the ratio of the Electricity production(% of total) of Korea (Democratic) in 2005 to that in 2011?
Provide a short and direct response. 1.39. What is the ratio of the Electricity production(% of total) in Montenegro in 2005 to that in 2011?
Your response must be concise. 0.64. What is the ratio of the Electricity production(% of total) in Pakistan in 2005 to that in 2011?
Provide a short and direct response. 1.36. What is the ratio of the Electricity production(% of total) in Slovak Republic in 2005 to that in 2011?
Offer a terse response. 1.34. What is the ratio of the Electricity production(% of total) of Korea (Democratic) in 2005 to that in 2012?
Keep it short and to the point. 1.45. What is the ratio of the Electricity production(% of total) of Montenegro in 2005 to that in 2012?
Make the answer very short. 0.72. What is the ratio of the Electricity production(% of total) in Pakistan in 2005 to that in 2012?
Ensure brevity in your answer.  2.17. What is the ratio of the Electricity production(% of total) in Slovak Republic in 2005 to that in 2012?
Your response must be concise. 1.38. What is the ratio of the Electricity production(% of total) in Korea (Democratic) in 2006 to that in 2007?
Provide a short and direct response. 1.18. What is the ratio of the Electricity production(% of total) of Montenegro in 2006 to that in 2007?
Offer a very short reply. 1.02. What is the ratio of the Electricity production(% of total) of Pakistan in 2006 to that in 2007?
Keep it short and to the point. 0.97. What is the ratio of the Electricity production(% of total) of Korea (Democratic) in 2006 to that in 2008?
Your response must be concise. 1.14. What is the ratio of the Electricity production(% of total) in Montenegro in 2006 to that in 2008?
Provide a short and direct response. 0.89. What is the ratio of the Electricity production(% of total) in Pakistan in 2006 to that in 2008?
Provide a short and direct response. 1.12. What is the ratio of the Electricity production(% of total) of Slovak Republic in 2006 to that in 2008?
Your answer should be compact. 1.02. What is the ratio of the Electricity production(% of total) in Korea (Democratic) in 2006 to that in 2009?
Keep it short and to the point. 1.08. What is the ratio of the Electricity production(% of total) of Montenegro in 2006 to that in 2009?
Offer a very short reply. 1.63. What is the ratio of the Electricity production(% of total) of Pakistan in 2006 to that in 2009?
Your response must be concise. 1.14. What is the ratio of the Electricity production(% of total) in Slovak Republic in 2006 to that in 2009?
Offer a very short reply. 1.11. What is the ratio of the Electricity production(% of total) in Korea (Democratic) in 2006 to that in 2010?
Give a very brief answer. 1.15. What is the ratio of the Electricity production(% of total) in Montenegro in 2006 to that in 2010?
Provide a short and direct response. 1.29. What is the ratio of the Electricity production(% of total) in Pakistan in 2006 to that in 2010?
Offer a very short reply. 1.49. What is the ratio of the Electricity production(% of total) of Slovak Republic in 2006 to that in 2010?
Give a very brief answer. 1.23. What is the ratio of the Electricity production(% of total) in Korea (Democratic) in 2006 to that in 2011?
Keep it short and to the point. 1.45. What is the ratio of the Electricity production(% of total) of Montenegro in 2006 to that in 2011?
Your answer should be very brief. 0.74. What is the ratio of the Electricity production(% of total) of Pakistan in 2006 to that in 2011?
Your response must be concise. 1.37. What is the ratio of the Electricity production(% of total) in Slovak Republic in 2006 to that in 2011?
Provide a succinct answer. 1.28. What is the ratio of the Electricity production(% of total) of Korea (Democratic) in 2006 to that in 2012?
Provide a short and direct response. 1.52. What is the ratio of the Electricity production(% of total) of Montenegro in 2006 to that in 2012?
Your answer should be very brief. 0.85. What is the ratio of the Electricity production(% of total) in Pakistan in 2006 to that in 2012?
Offer a terse response. 2.18. What is the ratio of the Electricity production(% of total) in Slovak Republic in 2006 to that in 2012?
Provide a succinct answer. 1.33. What is the ratio of the Electricity production(% of total) in Korea (Democratic) in 2007 to that in 2008?
Ensure brevity in your answer.  0.97. What is the ratio of the Electricity production(% of total) of Montenegro in 2007 to that in 2008?
Provide a short and direct response. 0.88. What is the ratio of the Electricity production(% of total) of Pakistan in 2007 to that in 2008?
Give a very brief answer. 1.15. What is the ratio of the Electricity production(% of total) in Slovak Republic in 2007 to that in 2008?
Offer a very short reply. 1.05. What is the ratio of the Electricity production(% of total) in Korea (Democratic) in 2007 to that in 2009?
Your answer should be very brief. 0.91. What is the ratio of the Electricity production(% of total) in Montenegro in 2007 to that in 2009?
Your answer should be compact. 1.61. What is the ratio of the Electricity production(% of total) of Pakistan in 2007 to that in 2009?
Offer a terse response. 1.17. What is the ratio of the Electricity production(% of total) of Slovak Republic in 2007 to that in 2009?
Your answer should be compact. 1.14. What is the ratio of the Electricity production(% of total) in Korea (Democratic) in 2007 to that in 2010?
Provide a succinct answer. 0.98. What is the ratio of the Electricity production(% of total) of Montenegro in 2007 to that in 2010?
Offer a very short reply. 1.27. What is the ratio of the Electricity production(% of total) of Pakistan in 2007 to that in 2010?
Provide a short and direct response. 1.52. What is the ratio of the Electricity production(% of total) in Slovak Republic in 2007 to that in 2010?
Offer a very short reply. 1.26. What is the ratio of the Electricity production(% of total) in Korea (Democratic) in 2007 to that in 2011?
Offer a very short reply. 1.24. What is the ratio of the Electricity production(% of total) in Montenegro in 2007 to that in 2011?
Provide a succinct answer. 0.73. What is the ratio of the Electricity production(% of total) in Pakistan in 2007 to that in 2011?
Your answer should be compact. 1.41. What is the ratio of the Electricity production(% of total) of Slovak Republic in 2007 to that in 2011?
Your response must be concise. 1.31. What is the ratio of the Electricity production(% of total) of Korea (Democratic) in 2007 to that in 2012?
Make the answer very short. 1.29. What is the ratio of the Electricity production(% of total) of Montenegro in 2007 to that in 2012?
Offer a terse response. 0.83. What is the ratio of the Electricity production(% of total) of Pakistan in 2007 to that in 2012?
Offer a very short reply. 2.24. What is the ratio of the Electricity production(% of total) of Slovak Republic in 2007 to that in 2012?
Provide a short and direct response. 1.36. What is the ratio of the Electricity production(% of total) of Korea (Democratic) in 2008 to that in 2009?
Make the answer very short. 0.95. What is the ratio of the Electricity production(% of total) in Montenegro in 2008 to that in 2009?
Your answer should be very brief. 1.83. What is the ratio of the Electricity production(% of total) in Pakistan in 2008 to that in 2009?
Make the answer very short. 1.01. What is the ratio of the Electricity production(% of total) in Slovak Republic in 2008 to that in 2009?
Your response must be concise. 1.09. What is the ratio of the Electricity production(% of total) of Korea (Democratic) in 2008 to that in 2010?
Provide a short and direct response. 1.01. What is the ratio of the Electricity production(% of total) in Montenegro in 2008 to that in 2010?
Offer a terse response. 1.44. What is the ratio of the Electricity production(% of total) in Pakistan in 2008 to that in 2010?
Offer a terse response. 1.32. What is the ratio of the Electricity production(% of total) in Slovak Republic in 2008 to that in 2010?
Offer a very short reply. 1.21. What is the ratio of the Electricity production(% of total) in Korea (Democratic) in 2008 to that in 2011?
Keep it short and to the point. 1.28. What is the ratio of the Electricity production(% of total) in Montenegro in 2008 to that in 2011?
Your answer should be compact. 0.83. What is the ratio of the Electricity production(% of total) of Pakistan in 2008 to that in 2011?
Your response must be concise. 1.22. What is the ratio of the Electricity production(% of total) in Slovak Republic in 2008 to that in 2011?
Offer a terse response. 1.25. What is the ratio of the Electricity production(% of total) of Korea (Democratic) in 2008 to that in 2012?
Provide a short and direct response. 1.34. What is the ratio of the Electricity production(% of total) in Montenegro in 2008 to that in 2012?
Keep it short and to the point. 0.95. What is the ratio of the Electricity production(% of total) in Pakistan in 2008 to that in 2012?
Keep it short and to the point. 1.94. What is the ratio of the Electricity production(% of total) of Slovak Republic in 2008 to that in 2012?
Your response must be concise. 1.3. What is the ratio of the Electricity production(% of total) in Korea (Democratic) in 2009 to that in 2010?
Your response must be concise. 1.07. What is the ratio of the Electricity production(% of total) in Montenegro in 2009 to that in 2010?
Your answer should be compact. 0.79. What is the ratio of the Electricity production(% of total) of Pakistan in 2009 to that in 2010?
Offer a terse response. 1.3. What is the ratio of the Electricity production(% of total) in Slovak Republic in 2009 to that in 2010?
Give a very brief answer. 1.11. What is the ratio of the Electricity production(% of total) of Korea (Democratic) in 2009 to that in 2011?
Provide a short and direct response. 1.35. What is the ratio of the Electricity production(% of total) in Montenegro in 2009 to that in 2011?
Keep it short and to the point. 0.46. What is the ratio of the Electricity production(% of total) of Pakistan in 2009 to that in 2011?
Provide a succinct answer. 1.2. What is the ratio of the Electricity production(% of total) in Slovak Republic in 2009 to that in 2011?
Offer a very short reply. 1.16. What is the ratio of the Electricity production(% of total) in Korea (Democratic) in 2009 to that in 2012?
Make the answer very short. 1.41. What is the ratio of the Electricity production(% of total) in Montenegro in 2009 to that in 2012?
Your answer should be compact. 0.52. What is the ratio of the Electricity production(% of total) of Pakistan in 2009 to that in 2012?
Give a very brief answer. 1.92. What is the ratio of the Electricity production(% of total) of Slovak Republic in 2009 to that in 2012?
Your response must be concise. 1.2. What is the ratio of the Electricity production(% of total) of Korea (Democratic) in 2010 to that in 2011?
Keep it short and to the point. 1.26. What is the ratio of the Electricity production(% of total) in Montenegro in 2010 to that in 2011?
Keep it short and to the point. 0.58. What is the ratio of the Electricity production(% of total) in Pakistan in 2010 to that in 2011?
Your answer should be compact. 0.92. What is the ratio of the Electricity production(% of total) of Slovak Republic in 2010 to that in 2011?
Make the answer very short. 1.04. What is the ratio of the Electricity production(% of total) in Korea (Democratic) in 2010 to that in 2012?
Make the answer very short. 1.32. What is the ratio of the Electricity production(% of total) in Montenegro in 2010 to that in 2012?
Your response must be concise. 0.66. What is the ratio of the Electricity production(% of total) in Pakistan in 2010 to that in 2012?
Offer a very short reply. 1.47. What is the ratio of the Electricity production(% of total) in Slovak Republic in 2010 to that in 2012?
Your response must be concise. 1.08. What is the ratio of the Electricity production(% of total) of Korea (Democratic) in 2011 to that in 2012?
Offer a terse response. 1.04. What is the ratio of the Electricity production(% of total) of Montenegro in 2011 to that in 2012?
Keep it short and to the point. 1.14. What is the ratio of the Electricity production(% of total) in Pakistan in 2011 to that in 2012?
Offer a terse response. 1.59. What is the ratio of the Electricity production(% of total) in Slovak Republic in 2011 to that in 2012?
Your answer should be compact. 1.04. What is the difference between the highest and the second highest Electricity production(% of total) in Korea (Democratic)?
Provide a short and direct response. 1.86. What is the difference between the highest and the second highest Electricity production(% of total) in Montenegro?
Offer a very short reply. 6.6. What is the difference between the highest and the second highest Electricity production(% of total) of Pakistan?
Ensure brevity in your answer.  0. What is the difference between the highest and the second highest Electricity production(% of total) in Slovak Republic?
Your answer should be very brief. 0.35. What is the difference between the highest and the lowest Electricity production(% of total) of Korea (Democratic)?
Provide a succinct answer. 13.95. What is the difference between the highest and the lowest Electricity production(% of total) of Montenegro?
Your answer should be very brief. 29.7. What is the difference between the highest and the lowest Electricity production(% of total) in Pakistan?
Offer a terse response. 0.08. What is the difference between the highest and the lowest Electricity production(% of total) in Slovak Republic?
Keep it short and to the point. 5.29. 